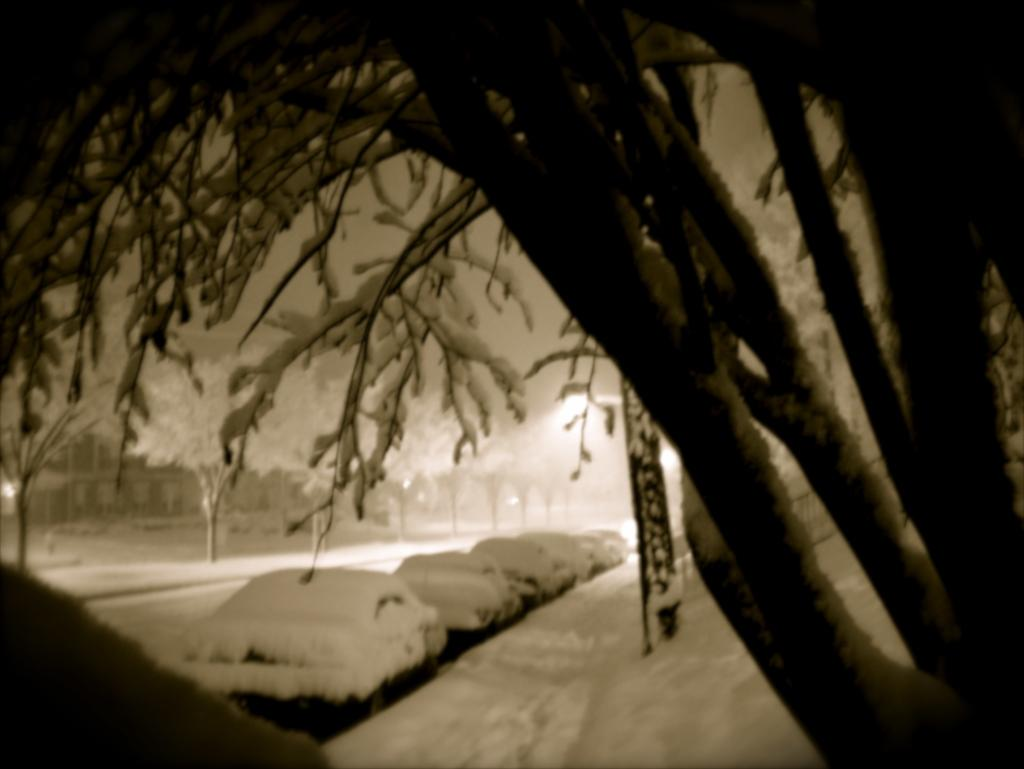What type of editing has been done to the image? The image is edited, but the specific type of editing is not mentioned in the facts. What can be seen in the background of the image? There are trees in the image. What is located in the middle of the image? There are cars in the middle of the image. What material is the image made of? The image consists of ice. What is covering the cars in the image? The cars are covered with ice. What type of coach can be seen in the image? There is no coach present in the image. 